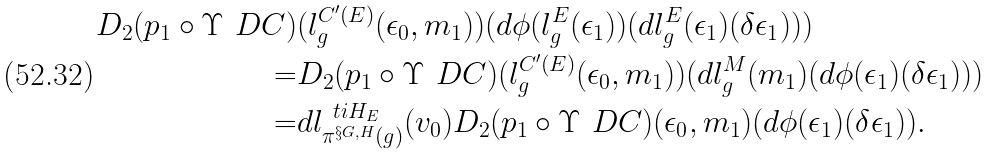<formula> <loc_0><loc_0><loc_500><loc_500>D _ { 2 } ( p _ { 1 } \circ \Upsilon _ { \ } D C ) & ( l ^ { C ^ { \prime } ( E ) } _ { g } ( \epsilon _ { 0 } , m _ { 1 } ) ) ( d \phi ( l ^ { E } _ { g } ( \epsilon _ { 1 } ) ) ( d l ^ { E } _ { g } ( \epsilon _ { 1 } ) ( \delta \epsilon _ { 1 } ) ) ) \\ = & D _ { 2 } ( p _ { 1 } \circ \Upsilon _ { \ } D C ) ( l ^ { C ^ { \prime } ( E ) } _ { g } ( \epsilon _ { 0 } , m _ { 1 } ) ) ( d l ^ { M } _ { g } ( m _ { 1 } ) ( d \phi ( \epsilon _ { 1 } ) ( \delta \epsilon _ { 1 } ) ) ) \\ = & d l ^ { \ t i { H } _ { E } } _ { \pi ^ { \S G , H } ( g ) } ( v _ { 0 } ) D _ { 2 } ( p _ { 1 } \circ \Upsilon _ { \ } D C ) ( \epsilon _ { 0 } , m _ { 1 } ) ( d \phi ( \epsilon _ { 1 } ) ( \delta \epsilon _ { 1 } ) ) .</formula> 